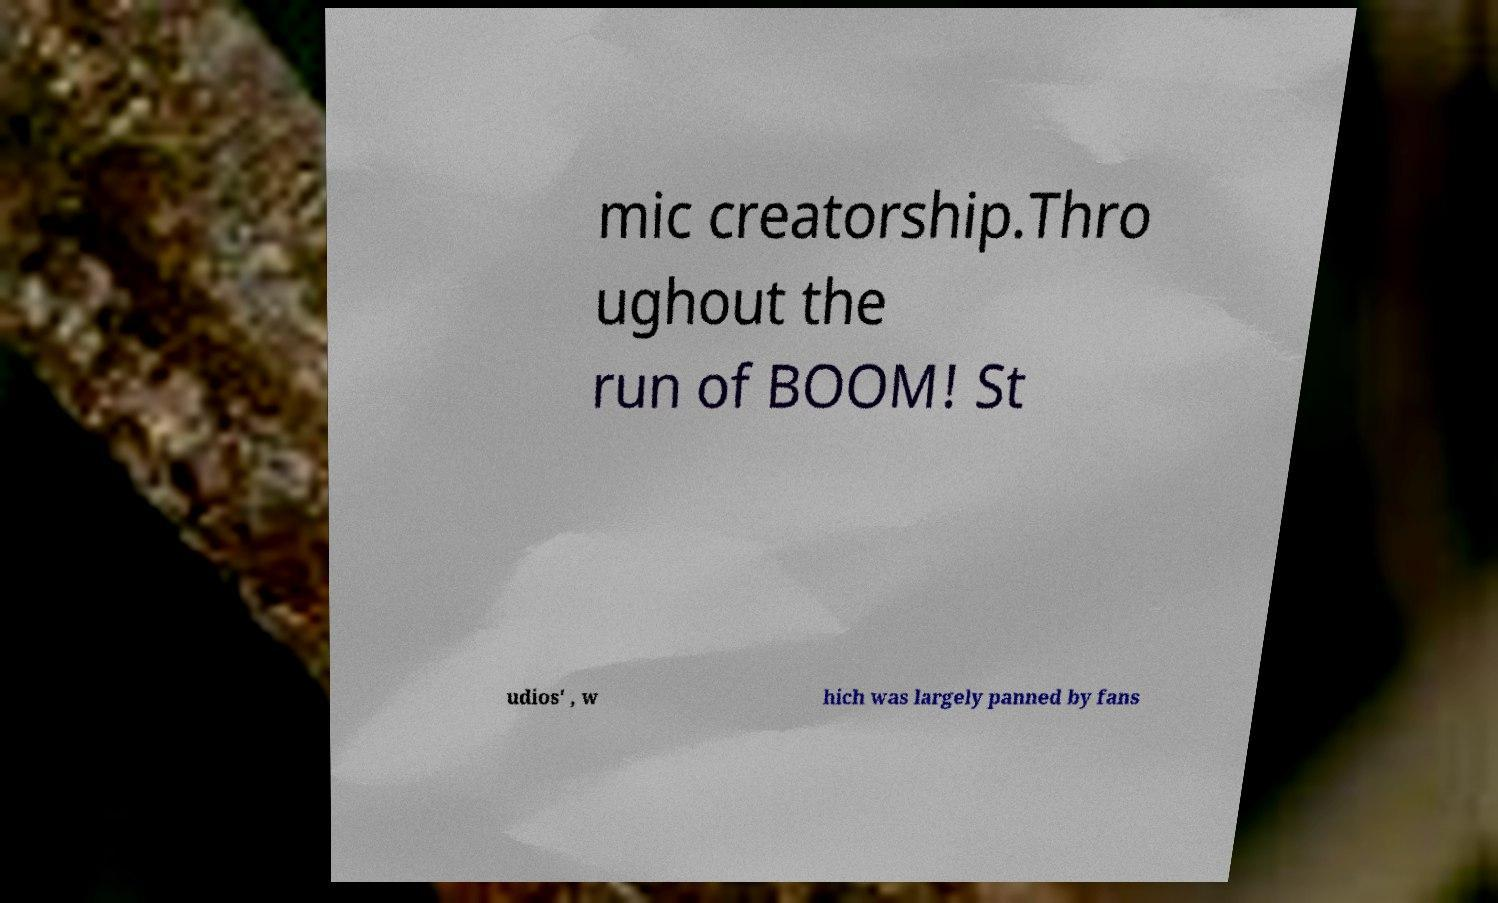Please read and relay the text visible in this image. What does it say? mic creatorship.Thro ughout the run of BOOM! St udios' , w hich was largely panned by fans 